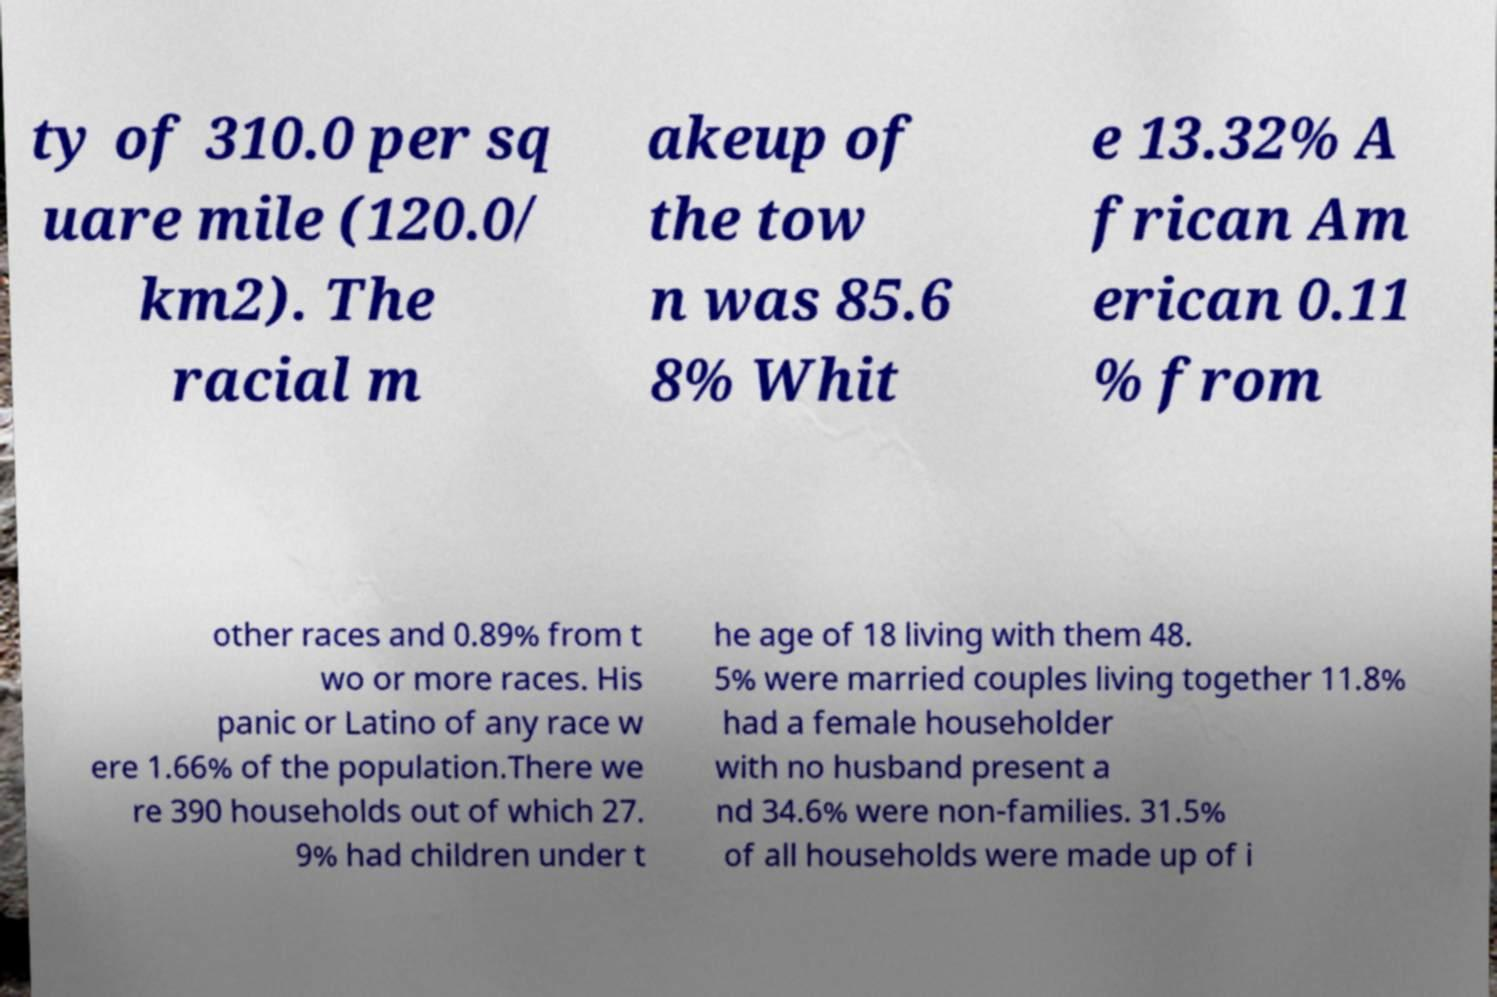Please identify and transcribe the text found in this image. ty of 310.0 per sq uare mile (120.0/ km2). The racial m akeup of the tow n was 85.6 8% Whit e 13.32% A frican Am erican 0.11 % from other races and 0.89% from t wo or more races. His panic or Latino of any race w ere 1.66% of the population.There we re 390 households out of which 27. 9% had children under t he age of 18 living with them 48. 5% were married couples living together 11.8% had a female householder with no husband present a nd 34.6% were non-families. 31.5% of all households were made up of i 